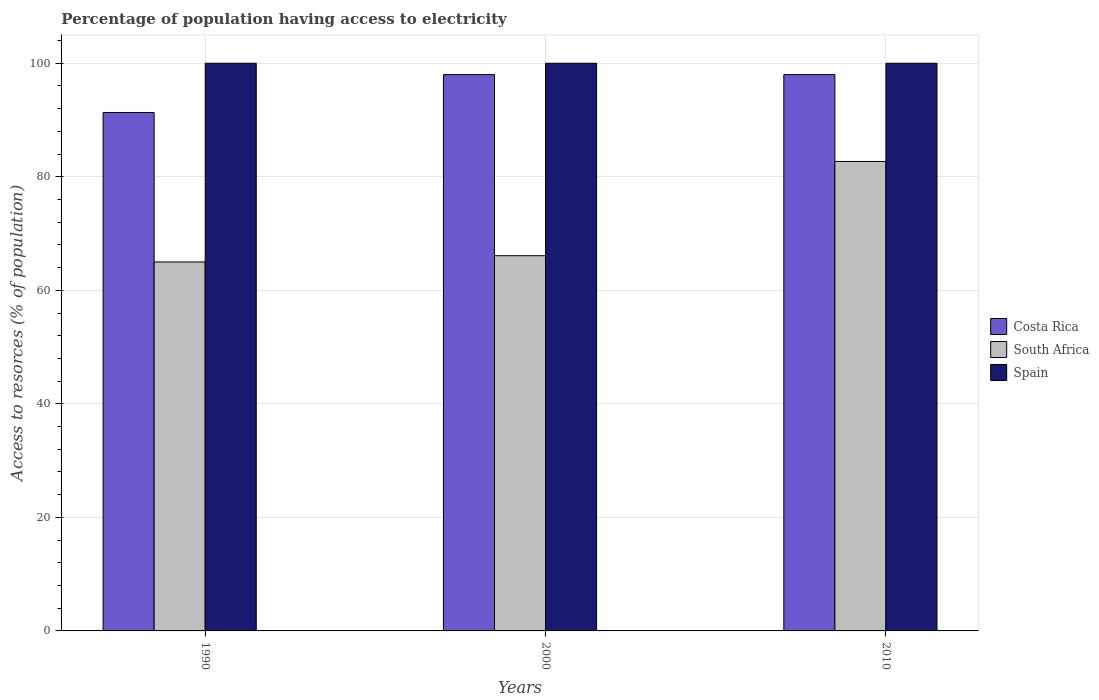Are the number of bars on each tick of the X-axis equal?
Provide a succinct answer. Yes. What is the label of the 1st group of bars from the left?
Make the answer very short. 1990. In how many cases, is the number of bars for a given year not equal to the number of legend labels?
Keep it short and to the point. 0. What is the percentage of population having access to electricity in South Africa in 1990?
Provide a succinct answer. 65. Across all years, what is the maximum percentage of population having access to electricity in Spain?
Make the answer very short. 100. Across all years, what is the minimum percentage of population having access to electricity in South Africa?
Make the answer very short. 65. In which year was the percentage of population having access to electricity in Costa Rica maximum?
Give a very brief answer. 2000. What is the total percentage of population having access to electricity in South Africa in the graph?
Offer a terse response. 213.8. What is the difference between the percentage of population having access to electricity in Spain in 2000 and that in 2010?
Provide a succinct answer. 0. In how many years, is the percentage of population having access to electricity in Costa Rica greater than 20 %?
Ensure brevity in your answer.  3. What is the ratio of the percentage of population having access to electricity in Spain in 1990 to that in 2010?
Offer a terse response. 1. Is the percentage of population having access to electricity in Costa Rica in 1990 less than that in 2010?
Offer a very short reply. Yes. Is the difference between the percentage of population having access to electricity in Costa Rica in 1990 and 2000 greater than the difference between the percentage of population having access to electricity in Spain in 1990 and 2000?
Offer a very short reply. No. What is the difference between the highest and the lowest percentage of population having access to electricity in South Africa?
Provide a succinct answer. 17.7. In how many years, is the percentage of population having access to electricity in South Africa greater than the average percentage of population having access to electricity in South Africa taken over all years?
Keep it short and to the point. 1. Is the sum of the percentage of population having access to electricity in Costa Rica in 2000 and 2010 greater than the maximum percentage of population having access to electricity in Spain across all years?
Give a very brief answer. Yes. What is the difference between two consecutive major ticks on the Y-axis?
Your answer should be very brief. 20. Where does the legend appear in the graph?
Make the answer very short. Center right. How many legend labels are there?
Ensure brevity in your answer.  3. How are the legend labels stacked?
Keep it short and to the point. Vertical. What is the title of the graph?
Your answer should be compact. Percentage of population having access to electricity. What is the label or title of the X-axis?
Give a very brief answer. Years. What is the label or title of the Y-axis?
Ensure brevity in your answer.  Access to resorces (% of population). What is the Access to resorces (% of population) of Costa Rica in 1990?
Ensure brevity in your answer.  91.33. What is the Access to resorces (% of population) of South Africa in 1990?
Offer a terse response. 65. What is the Access to resorces (% of population) in Spain in 1990?
Provide a succinct answer. 100. What is the Access to resorces (% of population) of South Africa in 2000?
Your answer should be compact. 66.1. What is the Access to resorces (% of population) of South Africa in 2010?
Your response must be concise. 82.7. What is the Access to resorces (% of population) in Spain in 2010?
Offer a terse response. 100. Across all years, what is the maximum Access to resorces (% of population) of Costa Rica?
Ensure brevity in your answer.  98. Across all years, what is the maximum Access to resorces (% of population) in South Africa?
Give a very brief answer. 82.7. Across all years, what is the maximum Access to resorces (% of population) of Spain?
Your answer should be compact. 100. Across all years, what is the minimum Access to resorces (% of population) in Costa Rica?
Make the answer very short. 91.33. Across all years, what is the minimum Access to resorces (% of population) in South Africa?
Ensure brevity in your answer.  65. What is the total Access to resorces (% of population) in Costa Rica in the graph?
Give a very brief answer. 287.33. What is the total Access to resorces (% of population) in South Africa in the graph?
Provide a short and direct response. 213.8. What is the total Access to resorces (% of population) in Spain in the graph?
Provide a short and direct response. 300. What is the difference between the Access to resorces (% of population) of Costa Rica in 1990 and that in 2000?
Provide a succinct answer. -6.67. What is the difference between the Access to resorces (% of population) of Costa Rica in 1990 and that in 2010?
Your response must be concise. -6.67. What is the difference between the Access to resorces (% of population) in South Africa in 1990 and that in 2010?
Provide a succinct answer. -17.7. What is the difference between the Access to resorces (% of population) of Costa Rica in 2000 and that in 2010?
Provide a succinct answer. 0. What is the difference between the Access to resorces (% of population) in South Africa in 2000 and that in 2010?
Provide a succinct answer. -16.6. What is the difference between the Access to resorces (% of population) of Costa Rica in 1990 and the Access to resorces (% of population) of South Africa in 2000?
Ensure brevity in your answer.  25.23. What is the difference between the Access to resorces (% of population) of Costa Rica in 1990 and the Access to resorces (% of population) of Spain in 2000?
Ensure brevity in your answer.  -8.67. What is the difference between the Access to resorces (% of population) in South Africa in 1990 and the Access to resorces (% of population) in Spain in 2000?
Provide a succinct answer. -35. What is the difference between the Access to resorces (% of population) in Costa Rica in 1990 and the Access to resorces (% of population) in South Africa in 2010?
Ensure brevity in your answer.  8.63. What is the difference between the Access to resorces (% of population) in Costa Rica in 1990 and the Access to resorces (% of population) in Spain in 2010?
Provide a short and direct response. -8.67. What is the difference between the Access to resorces (% of population) of South Africa in 1990 and the Access to resorces (% of population) of Spain in 2010?
Your response must be concise. -35. What is the difference between the Access to resorces (% of population) of Costa Rica in 2000 and the Access to resorces (% of population) of Spain in 2010?
Your answer should be very brief. -2. What is the difference between the Access to resorces (% of population) of South Africa in 2000 and the Access to resorces (% of population) of Spain in 2010?
Offer a very short reply. -33.9. What is the average Access to resorces (% of population) in Costa Rica per year?
Offer a terse response. 95.78. What is the average Access to resorces (% of population) in South Africa per year?
Your answer should be compact. 71.27. In the year 1990, what is the difference between the Access to resorces (% of population) of Costa Rica and Access to resorces (% of population) of South Africa?
Offer a terse response. 26.33. In the year 1990, what is the difference between the Access to resorces (% of population) in Costa Rica and Access to resorces (% of population) in Spain?
Your answer should be compact. -8.67. In the year 1990, what is the difference between the Access to resorces (% of population) in South Africa and Access to resorces (% of population) in Spain?
Your answer should be very brief. -35. In the year 2000, what is the difference between the Access to resorces (% of population) in Costa Rica and Access to resorces (% of population) in South Africa?
Ensure brevity in your answer.  31.9. In the year 2000, what is the difference between the Access to resorces (% of population) in Costa Rica and Access to resorces (% of population) in Spain?
Offer a very short reply. -2. In the year 2000, what is the difference between the Access to resorces (% of population) of South Africa and Access to resorces (% of population) of Spain?
Offer a very short reply. -33.9. In the year 2010, what is the difference between the Access to resorces (% of population) in Costa Rica and Access to resorces (% of population) in South Africa?
Keep it short and to the point. 15.3. In the year 2010, what is the difference between the Access to resorces (% of population) of Costa Rica and Access to resorces (% of population) of Spain?
Ensure brevity in your answer.  -2. In the year 2010, what is the difference between the Access to resorces (% of population) in South Africa and Access to resorces (% of population) in Spain?
Provide a short and direct response. -17.3. What is the ratio of the Access to resorces (% of population) of Costa Rica in 1990 to that in 2000?
Your answer should be compact. 0.93. What is the ratio of the Access to resorces (% of population) of South Africa in 1990 to that in 2000?
Your answer should be compact. 0.98. What is the ratio of the Access to resorces (% of population) of Spain in 1990 to that in 2000?
Your answer should be compact. 1. What is the ratio of the Access to resorces (% of population) of Costa Rica in 1990 to that in 2010?
Provide a short and direct response. 0.93. What is the ratio of the Access to resorces (% of population) in South Africa in 1990 to that in 2010?
Your response must be concise. 0.79. What is the ratio of the Access to resorces (% of population) in Spain in 1990 to that in 2010?
Ensure brevity in your answer.  1. What is the ratio of the Access to resorces (% of population) in Costa Rica in 2000 to that in 2010?
Offer a very short reply. 1. What is the ratio of the Access to resorces (% of population) of South Africa in 2000 to that in 2010?
Keep it short and to the point. 0.8. What is the difference between the highest and the second highest Access to resorces (% of population) of South Africa?
Your response must be concise. 16.6. What is the difference between the highest and the lowest Access to resorces (% of population) of Costa Rica?
Your answer should be compact. 6.67. What is the difference between the highest and the lowest Access to resorces (% of population) of South Africa?
Your response must be concise. 17.7. 